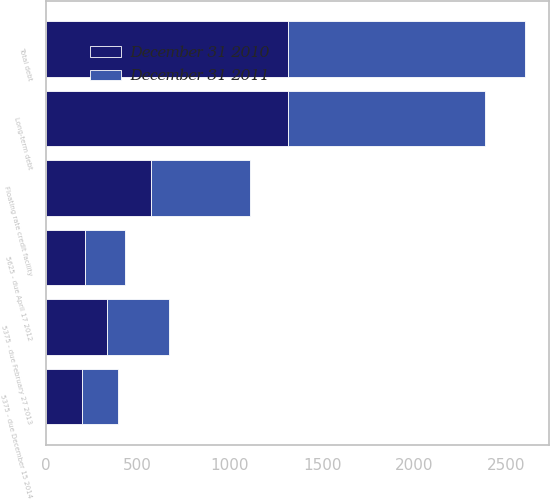<chart> <loc_0><loc_0><loc_500><loc_500><stacked_bar_chart><ecel><fcel>5625 - due April 17 2012<fcel>5375 - due February 27 2013<fcel>5375 - due December 15 2014<fcel>Floating rate credit facility<fcel>Total debt<fcel>Long-term debt<nl><fcel>December 31 2011<fcel>215.1<fcel>333.5<fcel>197.1<fcel>539<fcel>1284.7<fcel>1069.6<nl><fcel>December 31 2010<fcel>215.1<fcel>333.5<fcel>197.1<fcel>570<fcel>1315.7<fcel>1315.7<nl></chart> 